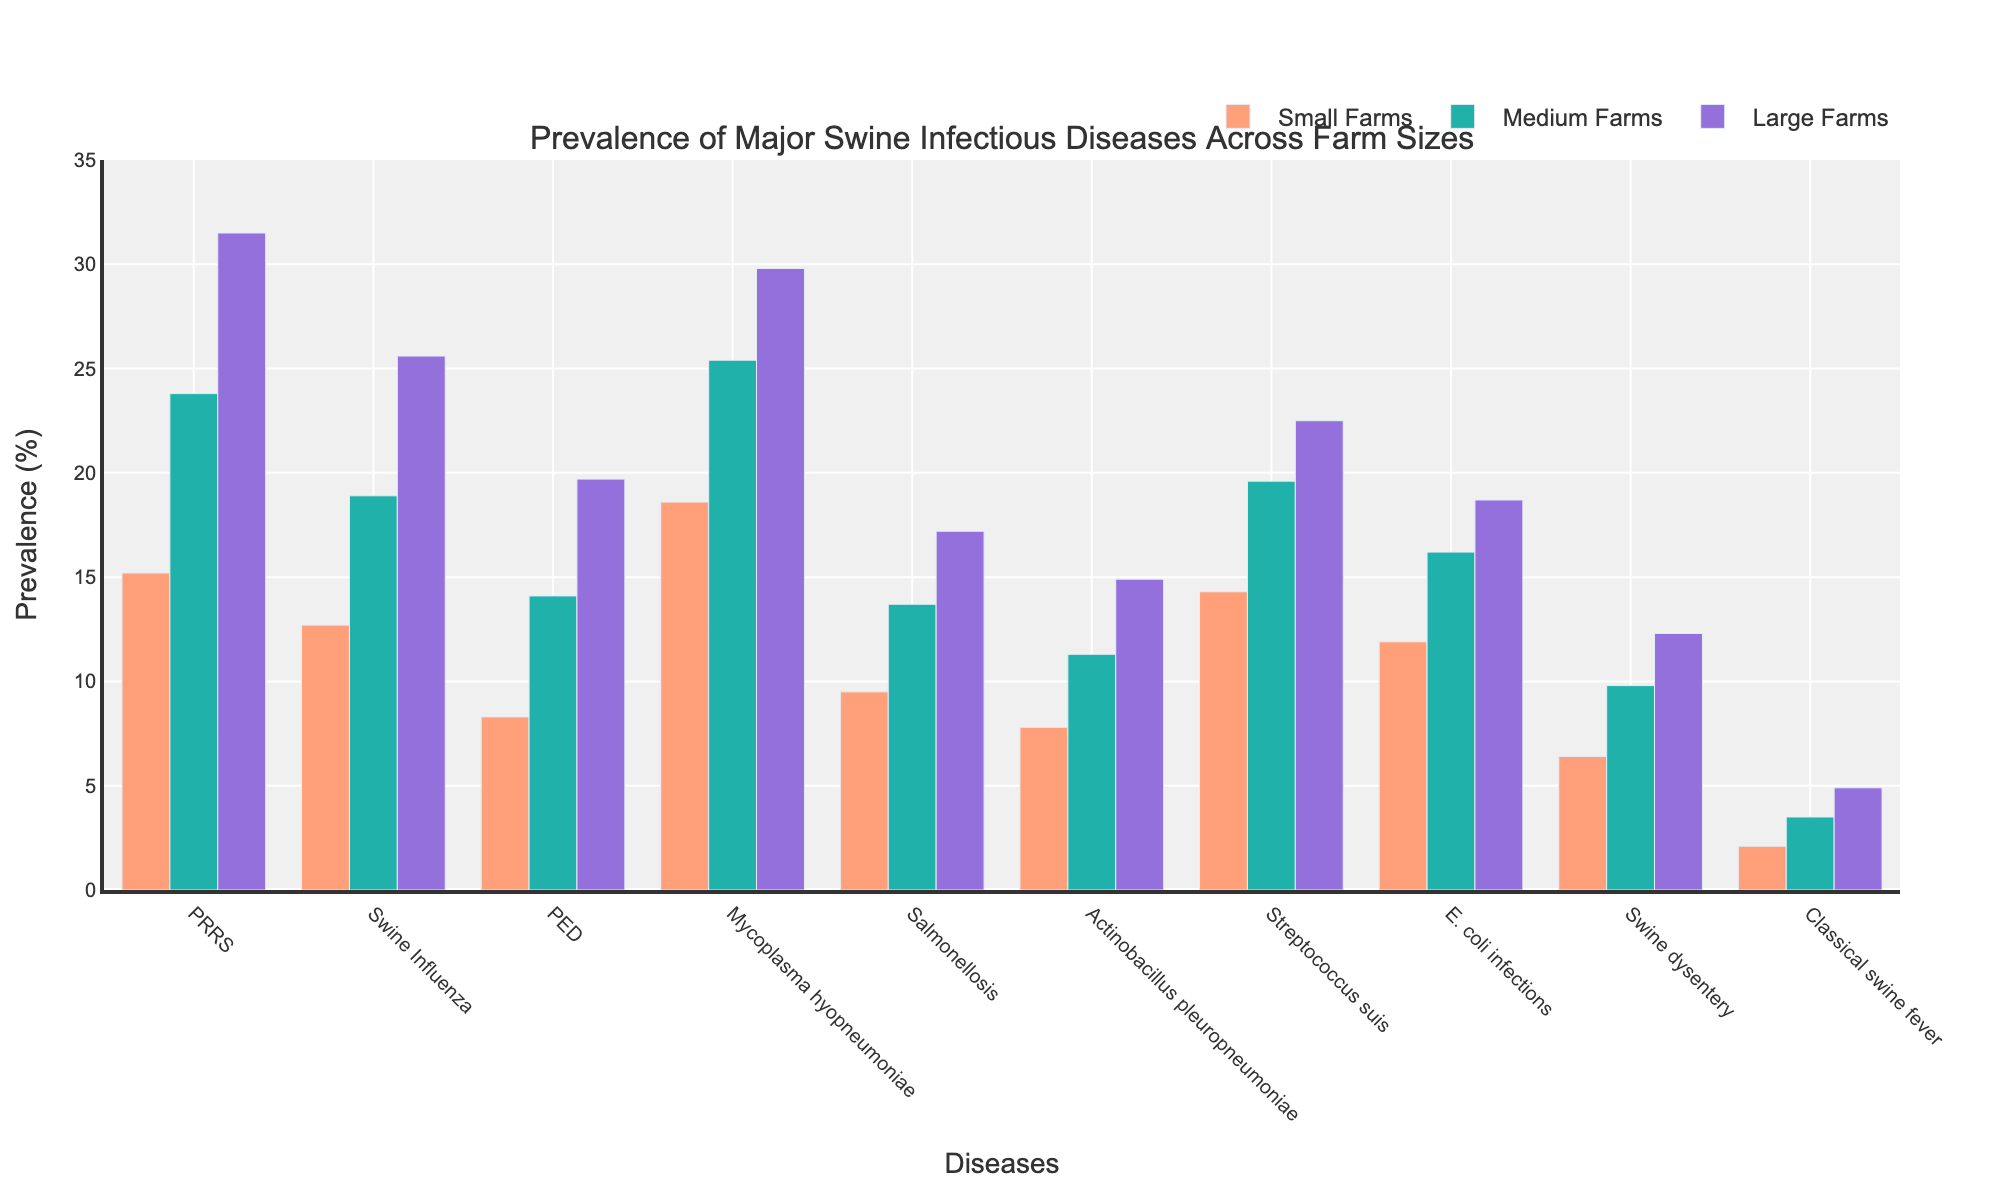What's the disease with the highest prevalence in large farms? Look at the bars representing the prevalence in large farms for each disease and identify the tallest bar. PRRS has the highest prevalence among the diseases in large farms with a percentage of 31.5.
Answer: PRRS Which farm size shows the least prevalence for Classical Swine Fever? Look at the bars for Classical Swine Fever in each farm size. The smallest bar corresponds to small farms, with a prevalence of 2.1%.
Answer: Small farms Compare the prevalence of Streptococcus suis between small farms and large farms. Look at the bars representing Streptococcus suis for small farms and large farms. The prevalence is 14.3% for small farms and 22.5% for large farms.
Answer: Large farms have a higher prevalence of Streptococcus suis compared to small farms What is the difference in the prevalence of Mycoplasma hyopneumoniae between medium farms and small farms? Subtract the prevalence percentage of Mycoplasma hyopneumoniae in small farms (18.6%) from that in medium farms (25.4%). The difference is 25.4% - 18.6% = 6.8%.
Answer: 6.8% Which disease shows the greatest increase in prevalence from small farms to large farms? Calculate the difference between the prevalence in large farms and small farms for each disease. PRRS shows the greatest increase with 31.5% (large farms) - 15.2% (small farms) = 16.3%.
Answer: PRRS What is the average prevalence of Swine Influenza across all farm sizes? Add the prevalence of Swine Influenza for small farms (12.7%), medium farms (18.9%), and large farms (25.6%) and then divide by 3. (12.7% + 18.9% + 25.6%) / 3 = 19.07%.
Answer: 19.07% Which farm size has the most balanced prevalence across all diseases? Look at the variation in bar heights for each farm size across all diseases. Medium farms seem to have relatively balanced heights across the diseases.
Answer: Medium farms What is the combined prevalence of E. coli infections and Swine dysentery in small farms? Add the prevalence of E. coli infections (11.9%) and Swine dysentery (6.4%) in small farms. The combined prevalence is 11.9% + 6.4% = 18.3%.
Answer: 18.3% How many diseases have a prevalence of more than 20% in large farms? Count the number of bars in the large farm category that exceed the 20% mark. There are four such diseases: PRRS, Swine Influenza, Mycoplasma hyopneumoniae, and Streptococcus suis.
Answer: 4 